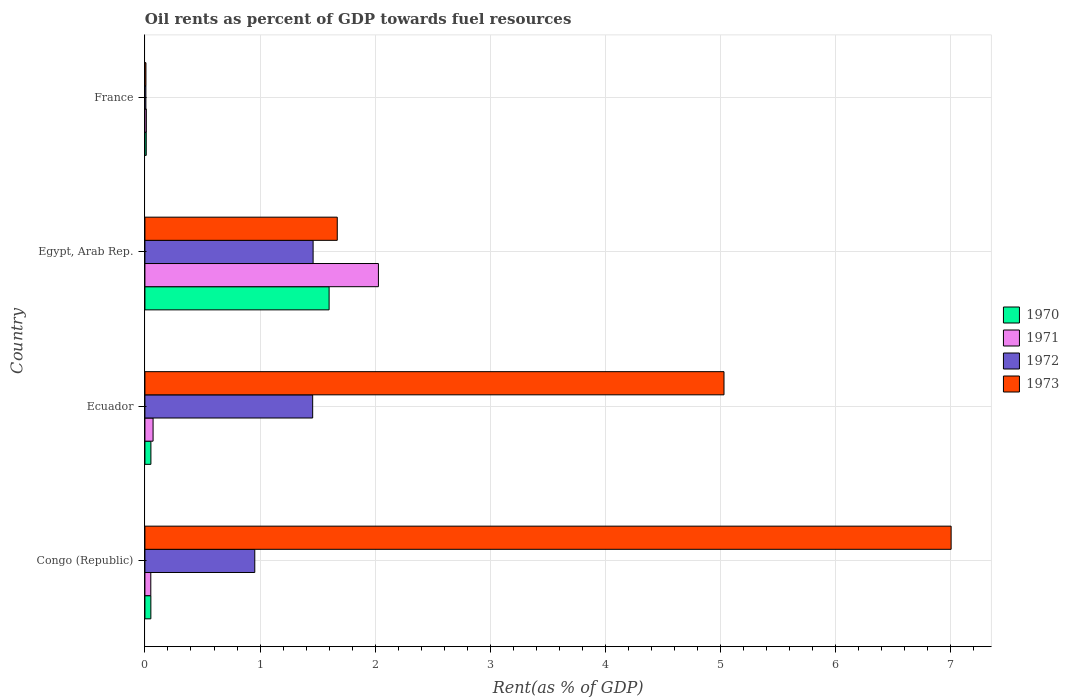Are the number of bars per tick equal to the number of legend labels?
Your response must be concise. Yes. Are the number of bars on each tick of the Y-axis equal?
Make the answer very short. Yes. What is the label of the 3rd group of bars from the top?
Your answer should be compact. Ecuador. What is the oil rent in 1971 in France?
Keep it short and to the point. 0.01. Across all countries, what is the maximum oil rent in 1970?
Your answer should be very brief. 1.6. Across all countries, what is the minimum oil rent in 1972?
Your answer should be compact. 0.01. In which country was the oil rent in 1970 maximum?
Give a very brief answer. Egypt, Arab Rep. In which country was the oil rent in 1972 minimum?
Your answer should be compact. France. What is the total oil rent in 1972 in the graph?
Offer a very short reply. 3.88. What is the difference between the oil rent in 1971 in Congo (Republic) and that in Ecuador?
Make the answer very short. -0.02. What is the difference between the oil rent in 1971 in Egypt, Arab Rep. and the oil rent in 1973 in Ecuador?
Keep it short and to the point. -3. What is the average oil rent in 1973 per country?
Provide a succinct answer. 3.43. What is the difference between the oil rent in 1970 and oil rent in 1973 in France?
Provide a succinct answer. 0. In how many countries, is the oil rent in 1971 greater than 2 %?
Ensure brevity in your answer.  1. What is the ratio of the oil rent in 1971 in Ecuador to that in France?
Give a very brief answer. 5.74. Is the difference between the oil rent in 1970 in Egypt, Arab Rep. and France greater than the difference between the oil rent in 1973 in Egypt, Arab Rep. and France?
Offer a terse response. No. What is the difference between the highest and the second highest oil rent in 1971?
Give a very brief answer. 1.96. What is the difference between the highest and the lowest oil rent in 1972?
Your answer should be compact. 1.45. In how many countries, is the oil rent in 1971 greater than the average oil rent in 1971 taken over all countries?
Provide a succinct answer. 1. Is the sum of the oil rent in 1971 in Congo (Republic) and Egypt, Arab Rep. greater than the maximum oil rent in 1970 across all countries?
Offer a very short reply. Yes. Is it the case that in every country, the sum of the oil rent in 1970 and oil rent in 1972 is greater than the sum of oil rent in 1971 and oil rent in 1973?
Your answer should be very brief. No. What does the 4th bar from the bottom in Congo (Republic) represents?
Make the answer very short. 1973. Is it the case that in every country, the sum of the oil rent in 1973 and oil rent in 1971 is greater than the oil rent in 1972?
Provide a short and direct response. Yes. How many bars are there?
Offer a terse response. 16. Are all the bars in the graph horizontal?
Offer a terse response. Yes. How many countries are there in the graph?
Provide a short and direct response. 4. What is the difference between two consecutive major ticks on the X-axis?
Give a very brief answer. 1. Does the graph contain any zero values?
Ensure brevity in your answer.  No. Where does the legend appear in the graph?
Provide a short and direct response. Center right. What is the title of the graph?
Ensure brevity in your answer.  Oil rents as percent of GDP towards fuel resources. Does "1967" appear as one of the legend labels in the graph?
Your response must be concise. No. What is the label or title of the X-axis?
Your response must be concise. Rent(as % of GDP). What is the label or title of the Y-axis?
Give a very brief answer. Country. What is the Rent(as % of GDP) of 1970 in Congo (Republic)?
Offer a very short reply. 0.05. What is the Rent(as % of GDP) in 1971 in Congo (Republic)?
Give a very brief answer. 0.05. What is the Rent(as % of GDP) in 1972 in Congo (Republic)?
Your response must be concise. 0.95. What is the Rent(as % of GDP) of 1973 in Congo (Republic)?
Your response must be concise. 7. What is the Rent(as % of GDP) of 1970 in Ecuador?
Keep it short and to the point. 0.05. What is the Rent(as % of GDP) of 1971 in Ecuador?
Keep it short and to the point. 0.07. What is the Rent(as % of GDP) of 1972 in Ecuador?
Provide a succinct answer. 1.46. What is the Rent(as % of GDP) in 1973 in Ecuador?
Ensure brevity in your answer.  5.03. What is the Rent(as % of GDP) in 1970 in Egypt, Arab Rep.?
Provide a succinct answer. 1.6. What is the Rent(as % of GDP) of 1971 in Egypt, Arab Rep.?
Offer a very short reply. 2.03. What is the Rent(as % of GDP) of 1972 in Egypt, Arab Rep.?
Offer a very short reply. 1.46. What is the Rent(as % of GDP) in 1973 in Egypt, Arab Rep.?
Offer a very short reply. 1.67. What is the Rent(as % of GDP) of 1970 in France?
Your response must be concise. 0.01. What is the Rent(as % of GDP) in 1971 in France?
Provide a succinct answer. 0.01. What is the Rent(as % of GDP) of 1972 in France?
Your answer should be very brief. 0.01. What is the Rent(as % of GDP) of 1973 in France?
Offer a terse response. 0.01. Across all countries, what is the maximum Rent(as % of GDP) of 1970?
Your response must be concise. 1.6. Across all countries, what is the maximum Rent(as % of GDP) of 1971?
Make the answer very short. 2.03. Across all countries, what is the maximum Rent(as % of GDP) of 1972?
Offer a very short reply. 1.46. Across all countries, what is the maximum Rent(as % of GDP) in 1973?
Give a very brief answer. 7. Across all countries, what is the minimum Rent(as % of GDP) in 1970?
Ensure brevity in your answer.  0.01. Across all countries, what is the minimum Rent(as % of GDP) in 1971?
Provide a short and direct response. 0.01. Across all countries, what is the minimum Rent(as % of GDP) of 1972?
Provide a short and direct response. 0.01. Across all countries, what is the minimum Rent(as % of GDP) in 1973?
Offer a terse response. 0.01. What is the total Rent(as % of GDP) of 1970 in the graph?
Make the answer very short. 1.71. What is the total Rent(as % of GDP) of 1971 in the graph?
Make the answer very short. 2.16. What is the total Rent(as % of GDP) in 1972 in the graph?
Provide a succinct answer. 3.88. What is the total Rent(as % of GDP) of 1973 in the graph?
Your answer should be compact. 13.71. What is the difference between the Rent(as % of GDP) of 1970 in Congo (Republic) and that in Ecuador?
Make the answer very short. -0. What is the difference between the Rent(as % of GDP) of 1971 in Congo (Republic) and that in Ecuador?
Your answer should be compact. -0.02. What is the difference between the Rent(as % of GDP) of 1972 in Congo (Republic) and that in Ecuador?
Offer a terse response. -0.5. What is the difference between the Rent(as % of GDP) of 1973 in Congo (Republic) and that in Ecuador?
Provide a succinct answer. 1.97. What is the difference between the Rent(as % of GDP) of 1970 in Congo (Republic) and that in Egypt, Arab Rep.?
Offer a terse response. -1.55. What is the difference between the Rent(as % of GDP) in 1971 in Congo (Republic) and that in Egypt, Arab Rep.?
Ensure brevity in your answer.  -1.98. What is the difference between the Rent(as % of GDP) in 1972 in Congo (Republic) and that in Egypt, Arab Rep.?
Offer a very short reply. -0.51. What is the difference between the Rent(as % of GDP) of 1973 in Congo (Republic) and that in Egypt, Arab Rep.?
Provide a short and direct response. 5.33. What is the difference between the Rent(as % of GDP) of 1970 in Congo (Republic) and that in France?
Make the answer very short. 0.04. What is the difference between the Rent(as % of GDP) in 1971 in Congo (Republic) and that in France?
Offer a terse response. 0.04. What is the difference between the Rent(as % of GDP) in 1972 in Congo (Republic) and that in France?
Ensure brevity in your answer.  0.95. What is the difference between the Rent(as % of GDP) in 1973 in Congo (Republic) and that in France?
Offer a very short reply. 6.99. What is the difference between the Rent(as % of GDP) in 1970 in Ecuador and that in Egypt, Arab Rep.?
Offer a very short reply. -1.55. What is the difference between the Rent(as % of GDP) in 1971 in Ecuador and that in Egypt, Arab Rep.?
Provide a succinct answer. -1.96. What is the difference between the Rent(as % of GDP) in 1972 in Ecuador and that in Egypt, Arab Rep.?
Offer a very short reply. -0. What is the difference between the Rent(as % of GDP) of 1973 in Ecuador and that in Egypt, Arab Rep.?
Make the answer very short. 3.36. What is the difference between the Rent(as % of GDP) in 1970 in Ecuador and that in France?
Provide a succinct answer. 0.04. What is the difference between the Rent(as % of GDP) in 1971 in Ecuador and that in France?
Give a very brief answer. 0.06. What is the difference between the Rent(as % of GDP) of 1972 in Ecuador and that in France?
Your response must be concise. 1.45. What is the difference between the Rent(as % of GDP) of 1973 in Ecuador and that in France?
Your answer should be very brief. 5.02. What is the difference between the Rent(as % of GDP) of 1970 in Egypt, Arab Rep. and that in France?
Ensure brevity in your answer.  1.59. What is the difference between the Rent(as % of GDP) in 1971 in Egypt, Arab Rep. and that in France?
Offer a very short reply. 2.02. What is the difference between the Rent(as % of GDP) in 1972 in Egypt, Arab Rep. and that in France?
Your answer should be very brief. 1.45. What is the difference between the Rent(as % of GDP) of 1973 in Egypt, Arab Rep. and that in France?
Provide a succinct answer. 1.66. What is the difference between the Rent(as % of GDP) of 1970 in Congo (Republic) and the Rent(as % of GDP) of 1971 in Ecuador?
Your answer should be compact. -0.02. What is the difference between the Rent(as % of GDP) of 1970 in Congo (Republic) and the Rent(as % of GDP) of 1972 in Ecuador?
Provide a short and direct response. -1.41. What is the difference between the Rent(as % of GDP) of 1970 in Congo (Republic) and the Rent(as % of GDP) of 1973 in Ecuador?
Give a very brief answer. -4.98. What is the difference between the Rent(as % of GDP) of 1971 in Congo (Republic) and the Rent(as % of GDP) of 1972 in Ecuador?
Give a very brief answer. -1.41. What is the difference between the Rent(as % of GDP) in 1971 in Congo (Republic) and the Rent(as % of GDP) in 1973 in Ecuador?
Your response must be concise. -4.98. What is the difference between the Rent(as % of GDP) of 1972 in Congo (Republic) and the Rent(as % of GDP) of 1973 in Ecuador?
Provide a succinct answer. -4.08. What is the difference between the Rent(as % of GDP) of 1970 in Congo (Republic) and the Rent(as % of GDP) of 1971 in Egypt, Arab Rep.?
Your answer should be very brief. -1.98. What is the difference between the Rent(as % of GDP) in 1970 in Congo (Republic) and the Rent(as % of GDP) in 1972 in Egypt, Arab Rep.?
Your answer should be compact. -1.41. What is the difference between the Rent(as % of GDP) in 1970 in Congo (Republic) and the Rent(as % of GDP) in 1973 in Egypt, Arab Rep.?
Give a very brief answer. -1.62. What is the difference between the Rent(as % of GDP) in 1971 in Congo (Republic) and the Rent(as % of GDP) in 1972 in Egypt, Arab Rep.?
Your response must be concise. -1.41. What is the difference between the Rent(as % of GDP) in 1971 in Congo (Republic) and the Rent(as % of GDP) in 1973 in Egypt, Arab Rep.?
Your answer should be compact. -1.62. What is the difference between the Rent(as % of GDP) in 1972 in Congo (Republic) and the Rent(as % of GDP) in 1973 in Egypt, Arab Rep.?
Your answer should be compact. -0.72. What is the difference between the Rent(as % of GDP) in 1970 in Congo (Republic) and the Rent(as % of GDP) in 1971 in France?
Keep it short and to the point. 0.04. What is the difference between the Rent(as % of GDP) of 1970 in Congo (Republic) and the Rent(as % of GDP) of 1972 in France?
Your answer should be very brief. 0.04. What is the difference between the Rent(as % of GDP) in 1970 in Congo (Republic) and the Rent(as % of GDP) in 1973 in France?
Your answer should be very brief. 0.04. What is the difference between the Rent(as % of GDP) in 1971 in Congo (Republic) and the Rent(as % of GDP) in 1972 in France?
Make the answer very short. 0.04. What is the difference between the Rent(as % of GDP) in 1971 in Congo (Republic) and the Rent(as % of GDP) in 1973 in France?
Your answer should be very brief. 0.04. What is the difference between the Rent(as % of GDP) in 1972 in Congo (Republic) and the Rent(as % of GDP) in 1973 in France?
Your answer should be compact. 0.95. What is the difference between the Rent(as % of GDP) of 1970 in Ecuador and the Rent(as % of GDP) of 1971 in Egypt, Arab Rep.?
Ensure brevity in your answer.  -1.98. What is the difference between the Rent(as % of GDP) in 1970 in Ecuador and the Rent(as % of GDP) in 1972 in Egypt, Arab Rep.?
Make the answer very short. -1.41. What is the difference between the Rent(as % of GDP) of 1970 in Ecuador and the Rent(as % of GDP) of 1973 in Egypt, Arab Rep.?
Make the answer very short. -1.62. What is the difference between the Rent(as % of GDP) of 1971 in Ecuador and the Rent(as % of GDP) of 1972 in Egypt, Arab Rep.?
Keep it short and to the point. -1.39. What is the difference between the Rent(as % of GDP) of 1971 in Ecuador and the Rent(as % of GDP) of 1973 in Egypt, Arab Rep.?
Keep it short and to the point. -1.6. What is the difference between the Rent(as % of GDP) of 1972 in Ecuador and the Rent(as % of GDP) of 1973 in Egypt, Arab Rep.?
Give a very brief answer. -0.21. What is the difference between the Rent(as % of GDP) of 1970 in Ecuador and the Rent(as % of GDP) of 1971 in France?
Your answer should be compact. 0.04. What is the difference between the Rent(as % of GDP) of 1970 in Ecuador and the Rent(as % of GDP) of 1972 in France?
Offer a terse response. 0.04. What is the difference between the Rent(as % of GDP) of 1970 in Ecuador and the Rent(as % of GDP) of 1973 in France?
Give a very brief answer. 0.04. What is the difference between the Rent(as % of GDP) of 1971 in Ecuador and the Rent(as % of GDP) of 1972 in France?
Your answer should be very brief. 0.06. What is the difference between the Rent(as % of GDP) in 1971 in Ecuador and the Rent(as % of GDP) in 1973 in France?
Ensure brevity in your answer.  0.06. What is the difference between the Rent(as % of GDP) of 1972 in Ecuador and the Rent(as % of GDP) of 1973 in France?
Offer a terse response. 1.45. What is the difference between the Rent(as % of GDP) of 1970 in Egypt, Arab Rep. and the Rent(as % of GDP) of 1971 in France?
Your response must be concise. 1.59. What is the difference between the Rent(as % of GDP) of 1970 in Egypt, Arab Rep. and the Rent(as % of GDP) of 1972 in France?
Ensure brevity in your answer.  1.59. What is the difference between the Rent(as % of GDP) of 1970 in Egypt, Arab Rep. and the Rent(as % of GDP) of 1973 in France?
Give a very brief answer. 1.59. What is the difference between the Rent(as % of GDP) of 1971 in Egypt, Arab Rep. and the Rent(as % of GDP) of 1972 in France?
Your answer should be very brief. 2.02. What is the difference between the Rent(as % of GDP) in 1971 in Egypt, Arab Rep. and the Rent(as % of GDP) in 1973 in France?
Provide a short and direct response. 2.02. What is the difference between the Rent(as % of GDP) of 1972 in Egypt, Arab Rep. and the Rent(as % of GDP) of 1973 in France?
Keep it short and to the point. 1.45. What is the average Rent(as % of GDP) in 1970 per country?
Provide a succinct answer. 0.43. What is the average Rent(as % of GDP) in 1971 per country?
Your response must be concise. 0.54. What is the average Rent(as % of GDP) of 1972 per country?
Your answer should be compact. 0.97. What is the average Rent(as % of GDP) of 1973 per country?
Provide a short and direct response. 3.43. What is the difference between the Rent(as % of GDP) in 1970 and Rent(as % of GDP) in 1971 in Congo (Republic)?
Keep it short and to the point. 0. What is the difference between the Rent(as % of GDP) of 1970 and Rent(as % of GDP) of 1972 in Congo (Republic)?
Give a very brief answer. -0.9. What is the difference between the Rent(as % of GDP) in 1970 and Rent(as % of GDP) in 1973 in Congo (Republic)?
Provide a short and direct response. -6.95. What is the difference between the Rent(as % of GDP) in 1971 and Rent(as % of GDP) in 1972 in Congo (Republic)?
Give a very brief answer. -0.9. What is the difference between the Rent(as % of GDP) in 1971 and Rent(as % of GDP) in 1973 in Congo (Republic)?
Provide a succinct answer. -6.95. What is the difference between the Rent(as % of GDP) of 1972 and Rent(as % of GDP) of 1973 in Congo (Republic)?
Provide a short and direct response. -6.05. What is the difference between the Rent(as % of GDP) of 1970 and Rent(as % of GDP) of 1971 in Ecuador?
Make the answer very short. -0.02. What is the difference between the Rent(as % of GDP) in 1970 and Rent(as % of GDP) in 1972 in Ecuador?
Ensure brevity in your answer.  -1.41. What is the difference between the Rent(as % of GDP) in 1970 and Rent(as % of GDP) in 1973 in Ecuador?
Offer a terse response. -4.98. What is the difference between the Rent(as % of GDP) in 1971 and Rent(as % of GDP) in 1972 in Ecuador?
Make the answer very short. -1.39. What is the difference between the Rent(as % of GDP) in 1971 and Rent(as % of GDP) in 1973 in Ecuador?
Your response must be concise. -4.96. What is the difference between the Rent(as % of GDP) of 1972 and Rent(as % of GDP) of 1973 in Ecuador?
Ensure brevity in your answer.  -3.57. What is the difference between the Rent(as % of GDP) in 1970 and Rent(as % of GDP) in 1971 in Egypt, Arab Rep.?
Your answer should be very brief. -0.43. What is the difference between the Rent(as % of GDP) of 1970 and Rent(as % of GDP) of 1972 in Egypt, Arab Rep.?
Provide a succinct answer. 0.14. What is the difference between the Rent(as % of GDP) in 1970 and Rent(as % of GDP) in 1973 in Egypt, Arab Rep.?
Your answer should be compact. -0.07. What is the difference between the Rent(as % of GDP) of 1971 and Rent(as % of GDP) of 1972 in Egypt, Arab Rep.?
Your response must be concise. 0.57. What is the difference between the Rent(as % of GDP) of 1971 and Rent(as % of GDP) of 1973 in Egypt, Arab Rep.?
Keep it short and to the point. 0.36. What is the difference between the Rent(as % of GDP) in 1972 and Rent(as % of GDP) in 1973 in Egypt, Arab Rep.?
Offer a very short reply. -0.21. What is the difference between the Rent(as % of GDP) in 1970 and Rent(as % of GDP) in 1971 in France?
Keep it short and to the point. -0. What is the difference between the Rent(as % of GDP) in 1970 and Rent(as % of GDP) in 1972 in France?
Your response must be concise. 0. What is the difference between the Rent(as % of GDP) in 1970 and Rent(as % of GDP) in 1973 in France?
Provide a succinct answer. 0. What is the difference between the Rent(as % of GDP) of 1971 and Rent(as % of GDP) of 1972 in France?
Your response must be concise. 0. What is the difference between the Rent(as % of GDP) in 1971 and Rent(as % of GDP) in 1973 in France?
Offer a very short reply. 0. What is the difference between the Rent(as % of GDP) in 1972 and Rent(as % of GDP) in 1973 in France?
Your response must be concise. -0. What is the ratio of the Rent(as % of GDP) in 1970 in Congo (Republic) to that in Ecuador?
Your response must be concise. 0.99. What is the ratio of the Rent(as % of GDP) in 1971 in Congo (Republic) to that in Ecuador?
Your answer should be compact. 0.72. What is the ratio of the Rent(as % of GDP) in 1972 in Congo (Republic) to that in Ecuador?
Ensure brevity in your answer.  0.65. What is the ratio of the Rent(as % of GDP) in 1973 in Congo (Republic) to that in Ecuador?
Your answer should be very brief. 1.39. What is the ratio of the Rent(as % of GDP) of 1970 in Congo (Republic) to that in Egypt, Arab Rep.?
Your response must be concise. 0.03. What is the ratio of the Rent(as % of GDP) in 1971 in Congo (Republic) to that in Egypt, Arab Rep.?
Offer a very short reply. 0.03. What is the ratio of the Rent(as % of GDP) of 1972 in Congo (Republic) to that in Egypt, Arab Rep.?
Keep it short and to the point. 0.65. What is the ratio of the Rent(as % of GDP) of 1973 in Congo (Republic) to that in Egypt, Arab Rep.?
Offer a very short reply. 4.19. What is the ratio of the Rent(as % of GDP) in 1970 in Congo (Republic) to that in France?
Offer a terse response. 4.49. What is the ratio of the Rent(as % of GDP) in 1971 in Congo (Republic) to that in France?
Your answer should be compact. 4.14. What is the ratio of the Rent(as % of GDP) of 1972 in Congo (Republic) to that in France?
Provide a succinct answer. 112.31. What is the ratio of the Rent(as % of GDP) of 1973 in Congo (Republic) to that in France?
Keep it short and to the point. 792.27. What is the ratio of the Rent(as % of GDP) of 1970 in Ecuador to that in Egypt, Arab Rep.?
Keep it short and to the point. 0.03. What is the ratio of the Rent(as % of GDP) of 1971 in Ecuador to that in Egypt, Arab Rep.?
Your answer should be compact. 0.03. What is the ratio of the Rent(as % of GDP) in 1972 in Ecuador to that in Egypt, Arab Rep.?
Keep it short and to the point. 1. What is the ratio of the Rent(as % of GDP) in 1973 in Ecuador to that in Egypt, Arab Rep.?
Give a very brief answer. 3.01. What is the ratio of the Rent(as % of GDP) in 1970 in Ecuador to that in France?
Your answer should be compact. 4.52. What is the ratio of the Rent(as % of GDP) in 1971 in Ecuador to that in France?
Ensure brevity in your answer.  5.74. What is the ratio of the Rent(as % of GDP) in 1972 in Ecuador to that in France?
Keep it short and to the point. 171.48. What is the ratio of the Rent(as % of GDP) in 1973 in Ecuador to that in France?
Offer a terse response. 569.07. What is the ratio of the Rent(as % of GDP) in 1970 in Egypt, Arab Rep. to that in France?
Give a very brief answer. 139.1. What is the ratio of the Rent(as % of GDP) of 1971 in Egypt, Arab Rep. to that in France?
Your answer should be very brief. 164.4. What is the ratio of the Rent(as % of GDP) of 1972 in Egypt, Arab Rep. to that in France?
Make the answer very short. 171.93. What is the ratio of the Rent(as % of GDP) in 1973 in Egypt, Arab Rep. to that in France?
Keep it short and to the point. 189.03. What is the difference between the highest and the second highest Rent(as % of GDP) in 1970?
Make the answer very short. 1.55. What is the difference between the highest and the second highest Rent(as % of GDP) in 1971?
Ensure brevity in your answer.  1.96. What is the difference between the highest and the second highest Rent(as % of GDP) in 1972?
Provide a succinct answer. 0. What is the difference between the highest and the second highest Rent(as % of GDP) in 1973?
Keep it short and to the point. 1.97. What is the difference between the highest and the lowest Rent(as % of GDP) of 1970?
Your answer should be compact. 1.59. What is the difference between the highest and the lowest Rent(as % of GDP) in 1971?
Your response must be concise. 2.02. What is the difference between the highest and the lowest Rent(as % of GDP) in 1972?
Give a very brief answer. 1.45. What is the difference between the highest and the lowest Rent(as % of GDP) in 1973?
Give a very brief answer. 6.99. 